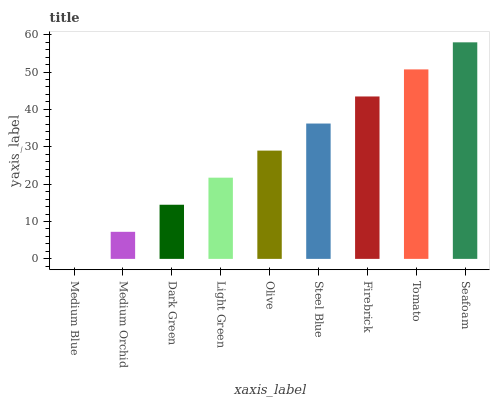Is Medium Blue the minimum?
Answer yes or no. Yes. Is Seafoam the maximum?
Answer yes or no. Yes. Is Medium Orchid the minimum?
Answer yes or no. No. Is Medium Orchid the maximum?
Answer yes or no. No. Is Medium Orchid greater than Medium Blue?
Answer yes or no. Yes. Is Medium Blue less than Medium Orchid?
Answer yes or no. Yes. Is Medium Blue greater than Medium Orchid?
Answer yes or no. No. Is Medium Orchid less than Medium Blue?
Answer yes or no. No. Is Olive the high median?
Answer yes or no. Yes. Is Olive the low median?
Answer yes or no. Yes. Is Seafoam the high median?
Answer yes or no. No. Is Light Green the low median?
Answer yes or no. No. 